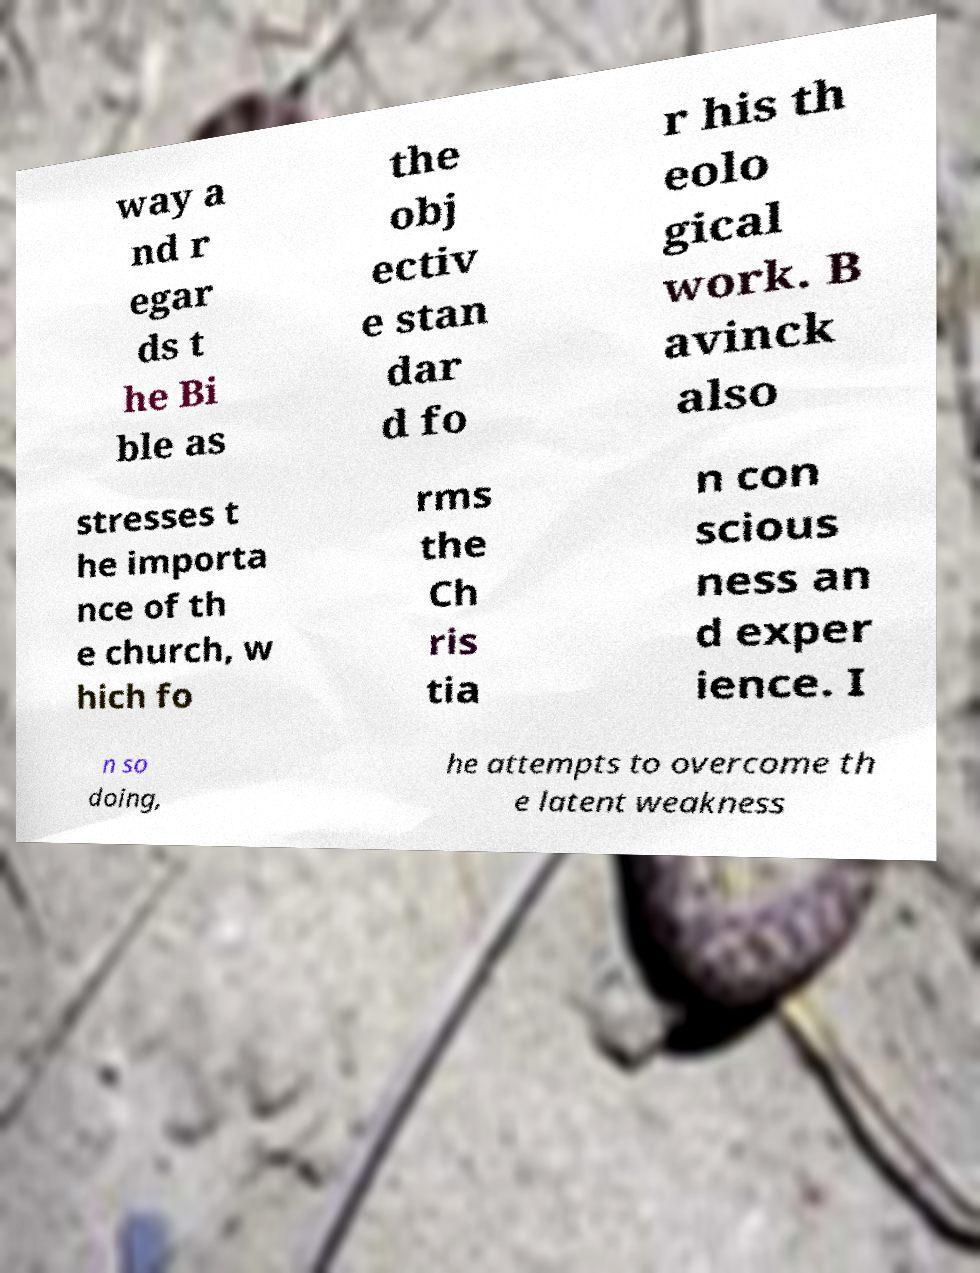Please read and relay the text visible in this image. What does it say? way a nd r egar ds t he Bi ble as the obj ectiv e stan dar d fo r his th eolo gical work. B avinck also stresses t he importa nce of th e church, w hich fo rms the Ch ris tia n con scious ness an d exper ience. I n so doing, he attempts to overcome th e latent weakness 